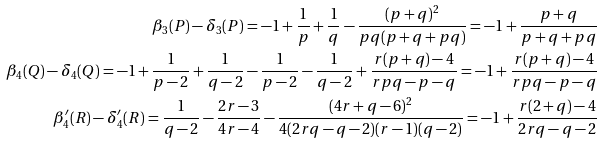Convert formula to latex. <formula><loc_0><loc_0><loc_500><loc_500>\beta _ { 3 } ( P ) - \delta _ { 3 } ( P ) = - 1 + \frac { 1 } { p } + \frac { 1 } { q } - \frac { ( p + q ) ^ { 2 } } { p q ( p + q + p q ) } = - 1 + \frac { p + q } { p + q + p q } \\ \beta _ { 4 } ( Q ) - \delta _ { 4 } ( Q ) = - 1 + \frac { 1 } { p - 2 } + \frac { 1 } { q - 2 } - \frac { 1 } { p - 2 } - \frac { 1 } { q - 2 } + \frac { r ( p + q ) - 4 } { r p q - p - q } = - 1 + \frac { r ( p + q ) - 4 } { r p q - p - q } \\ \beta ^ { \prime } _ { 4 } ( R ) - \delta ^ { \prime } _ { 4 } ( R ) = \frac { 1 } { q - 2 } - \frac { 2 r - 3 } { 4 r - 4 } - \frac { ( 4 r + q - 6 ) ^ { 2 } } { 4 ( 2 r q - q - 2 ) ( r - 1 ) ( q - 2 ) } = - 1 + \frac { r ( 2 + q ) - 4 } { 2 r q - q - 2 }</formula> 